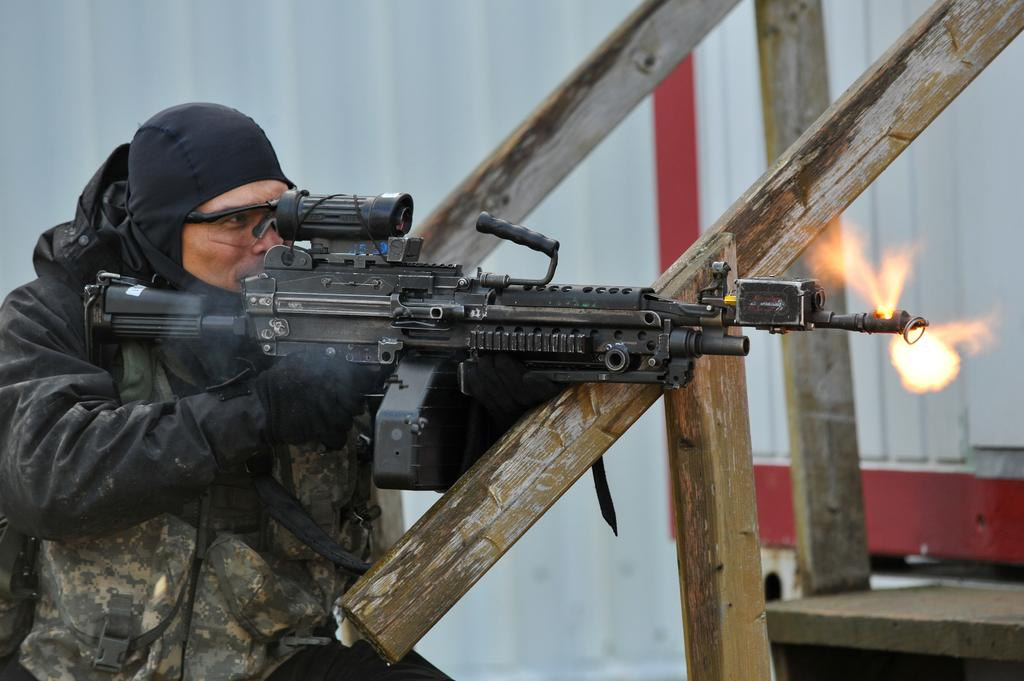Who is present in the image? There is a person in the image. What is the person holding in the image? The person is holding a machine gun. What type of underwear is the person wearing in the image? There is no information about the person's underwear in the image, so it cannot be determined. 